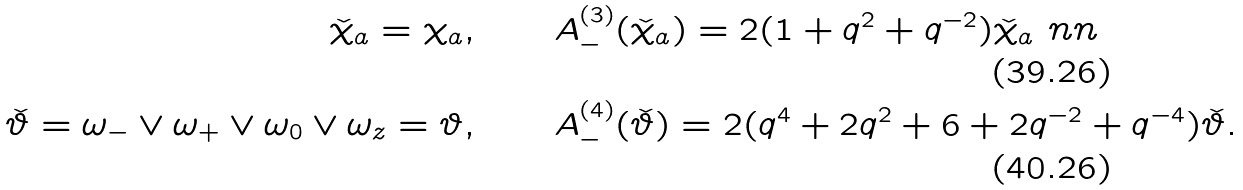<formula> <loc_0><loc_0><loc_500><loc_500>\check { \chi } _ { a } = \chi _ { a } , \quad & \quad A _ { - } ^ { ( 3 ) } ( \check { \chi } _ { a } ) = 2 ( 1 + q ^ { 2 } + q ^ { - 2 } ) \check { \chi } _ { a } \ n n \\ \check { \vartheta } = \omega _ { - } \vee \omega _ { + } \vee \omega _ { 0 } \vee \omega _ { z } = \vartheta , \quad & \quad A _ { - } ^ { ( 4 ) } ( \check { \vartheta } ) = 2 ( q ^ { 4 } + 2 q ^ { 2 } + 6 + 2 q ^ { - 2 } + q ^ { - 4 } ) \check { \vartheta } .</formula> 